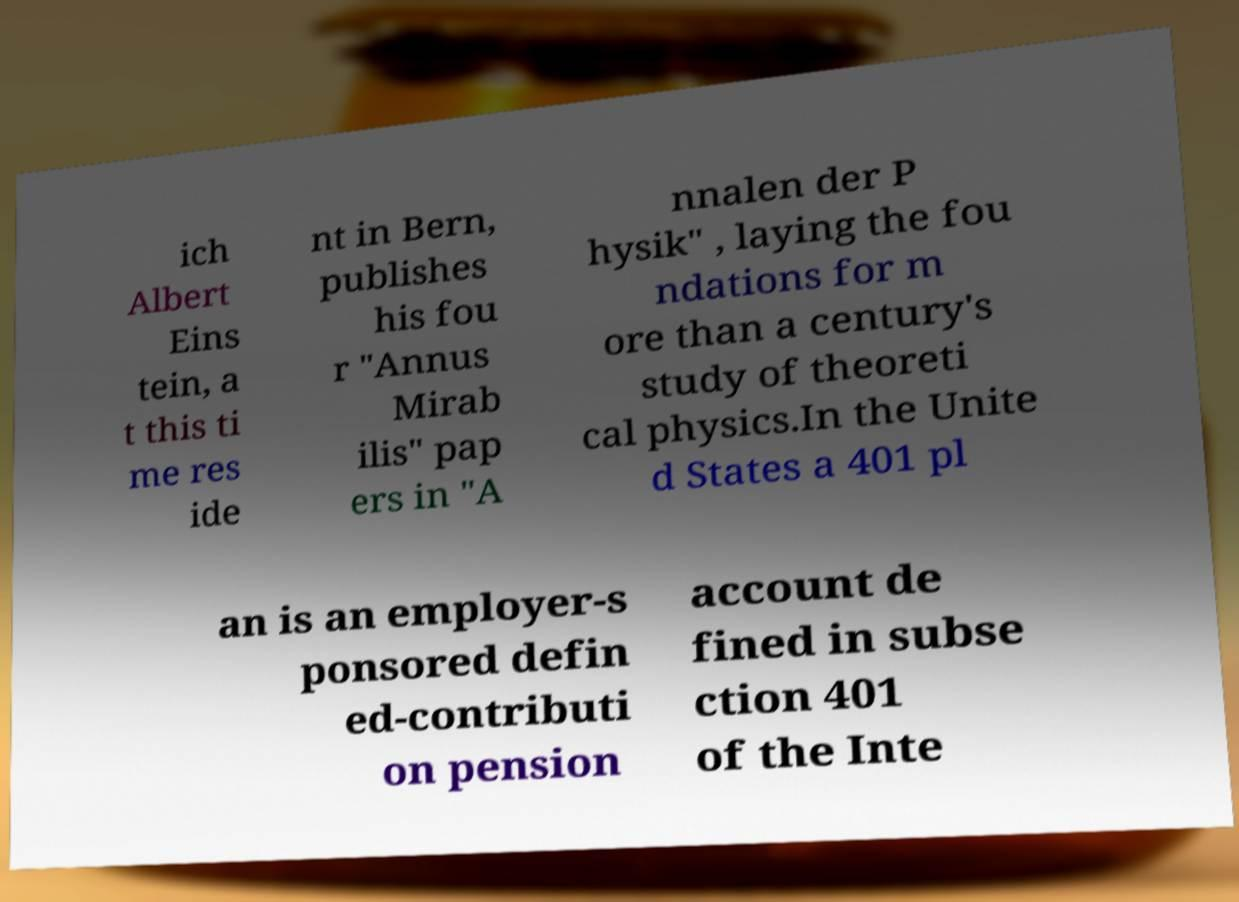Please identify and transcribe the text found in this image. ich Albert Eins tein, a t this ti me res ide nt in Bern, publishes his fou r "Annus Mirab ilis" pap ers in "A nnalen der P hysik" , laying the fou ndations for m ore than a century's study of theoreti cal physics.In the Unite d States a 401 pl an is an employer-s ponsored defin ed-contributi on pension account de fined in subse ction 401 of the Inte 